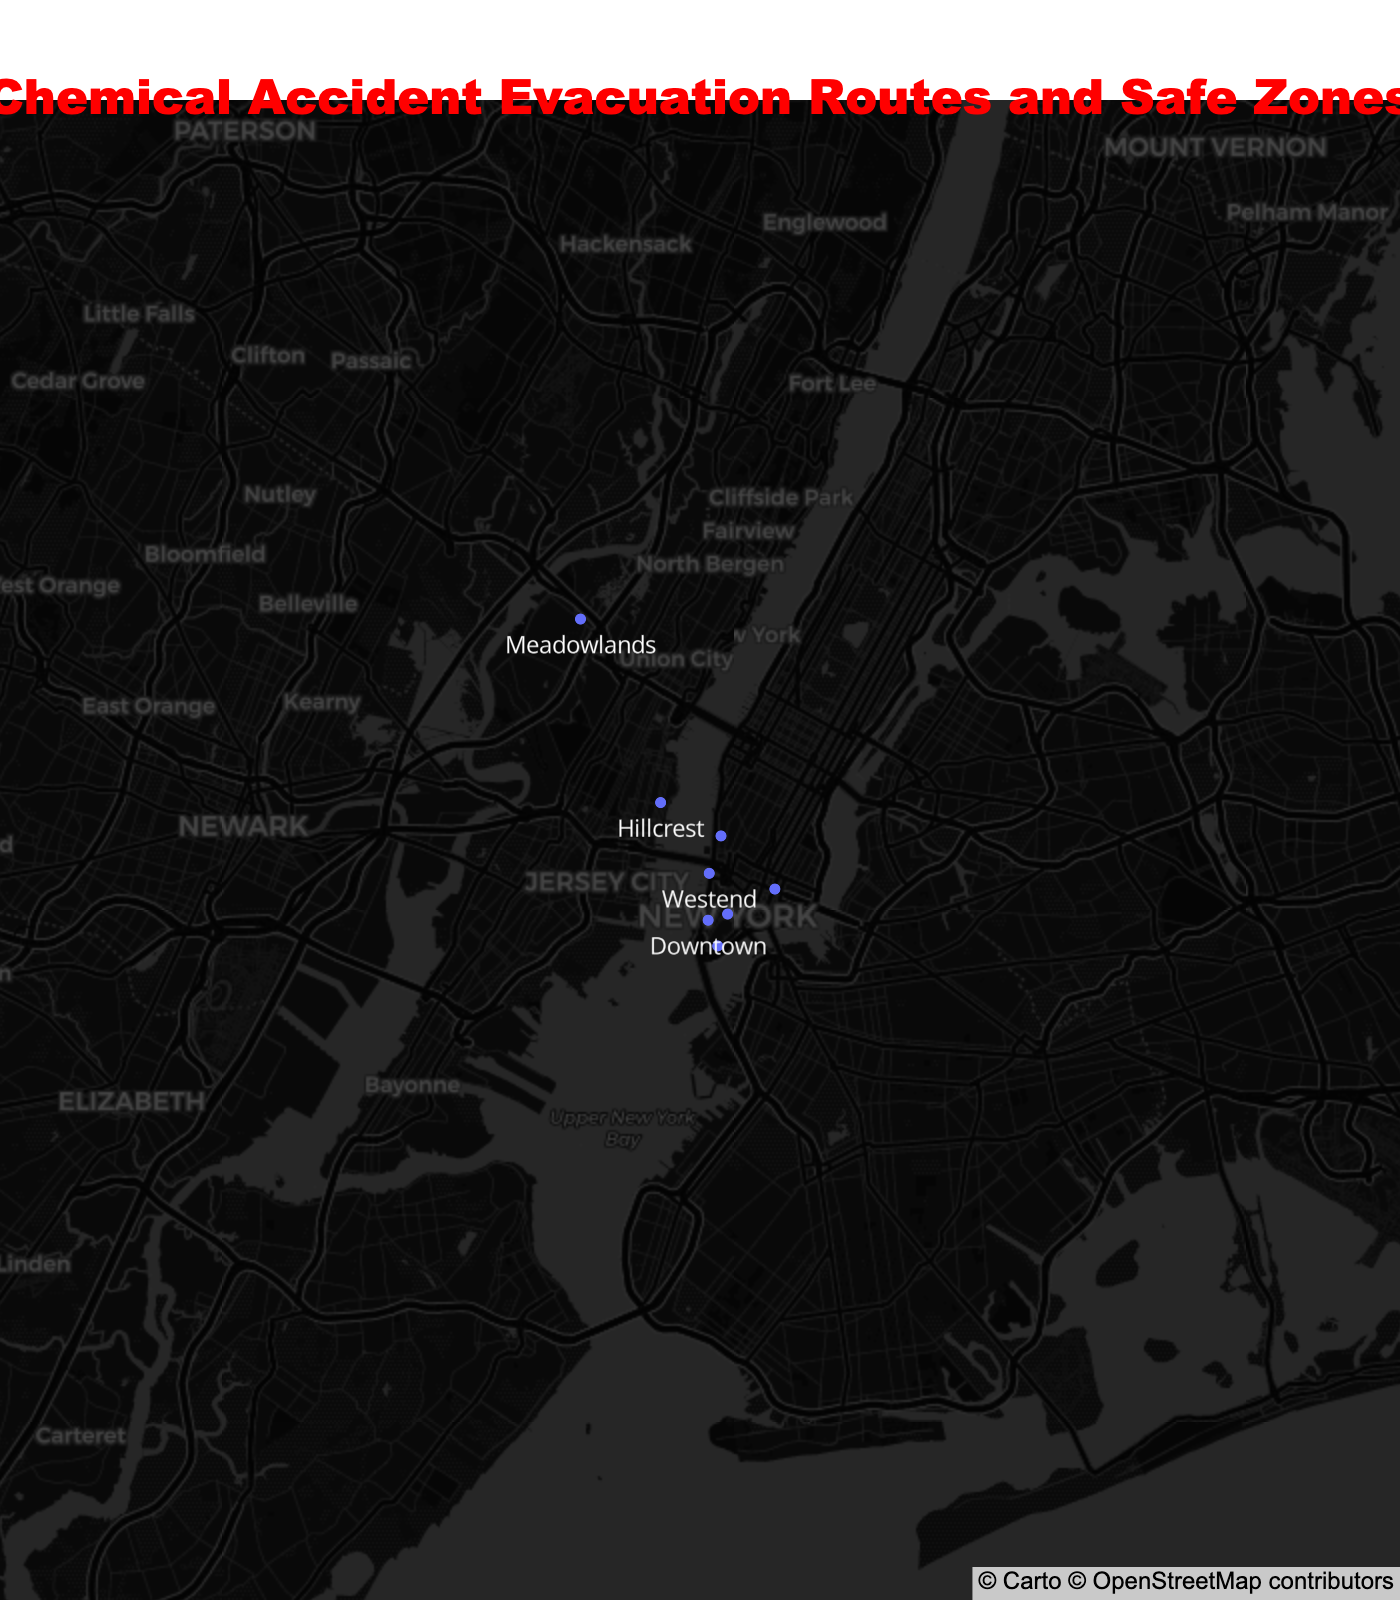Which neighborhood's evacuation route is Route 9 North? We locate the neighborhood that has Route 9 North listed under the Evacuation_Route column. From the figure, this neighborhood is Northside.
Answer: Northside What is the title of the figure? The title is displayed at the top of the figure in a larger and distinct font. It reads "Chemical Accident Evacuation Routes and Safe Zones".
Answer: Chemical Accident Evacuation Routes and Safe Zones Which neighborhood is closest to MetLife Stadium as the safe zone? We identify MetLife Stadium labeled on the map and check the corresponding neighborhood. The neighborhood connected to MetLife Stadium as the safe zone is Meadowlands.
Answer: Meadowlands Compare the evacuation routes and safe zones for Downtown and Riverside. Which are they? Downtown's evacuation route and safe zone are Holland Tunnel and Ellis Island respectively, while Riverside's evacuation route and safe zone are Pulaski Skyway and Liberty Science Center respectively.
Answer: Downtown: Holland Tunnel, Ellis Island. Riverside: Pulaski Skyway, Liberty Science Center How many neighborhoods have their safe zone located in a park? By examining the map: Lincoln Park (Northside), Central Park (Eastville), and Palisades Interstate Park (Hillcrest) are all parks, totaling three neighborhoods.
Answer: 3 What chemical plant is associated with Eastville? By looking at the data points, we locate Eastville and check the hover information which shows the chemical plant. The chemical plant for Eastville is NanoMat Industries.
Answer: NanoMat Industries Which neighborhood is plotted farthest north based on the latitude? By comparing the latitudes of all neighborhoods, Meadowlands has the highest latitude value (40.7895).
Answer: Meadowlands Are any neighborhoods sharing the same safe zone? By examining each neighborhood's safe zone on the map, Liberty State Park appears both for Westend and Riverside.
Answer: Yes, Westend and Riverside What evacuation route should residents of Southbridge take during a chemical accident? By referencing the map, Southbridge should use the Garden State Parkway South as its evacuation route.
Answer: Garden State Parkway South Which neighborhood requires evacuation via Holland Tunnel? Referring to the evacuation route in the map specific to Holland Tunnel, Downtown is the neighborhood listed.
Answer: Downtown 